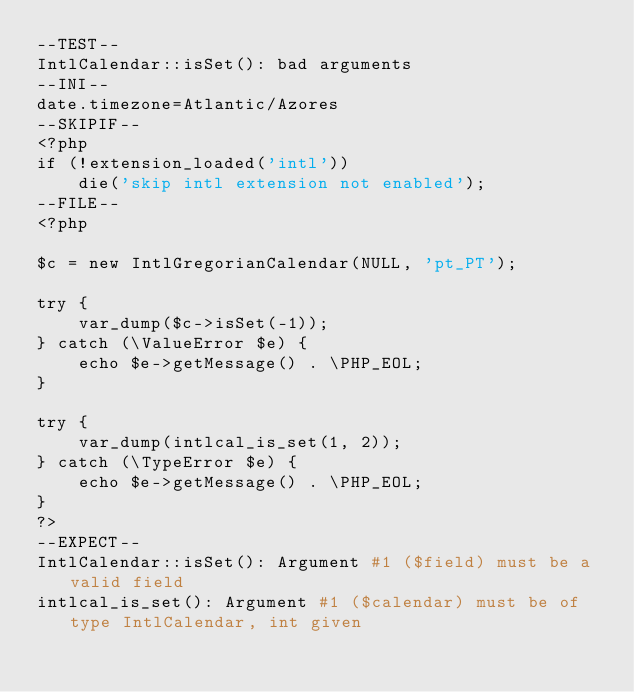Convert code to text. <code><loc_0><loc_0><loc_500><loc_500><_PHP_>--TEST--
IntlCalendar::isSet(): bad arguments
--INI--
date.timezone=Atlantic/Azores
--SKIPIF--
<?php
if (!extension_loaded('intl'))
	die('skip intl extension not enabled');
--FILE--
<?php

$c = new IntlGregorianCalendar(NULL, 'pt_PT');

try {
    var_dump($c->isSet(-1));
} catch (\ValueError $e) {
    echo $e->getMessage() . \PHP_EOL;
}

try {
    var_dump(intlcal_is_set(1, 2));
} catch (\TypeError $e) {
    echo $e->getMessage() . \PHP_EOL;
}
?>
--EXPECT--
IntlCalendar::isSet(): Argument #1 ($field) must be a valid field
intlcal_is_set(): Argument #1 ($calendar) must be of type IntlCalendar, int given
</code> 